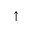<formula> <loc_0><loc_0><loc_500><loc_500>\uparrow</formula> 